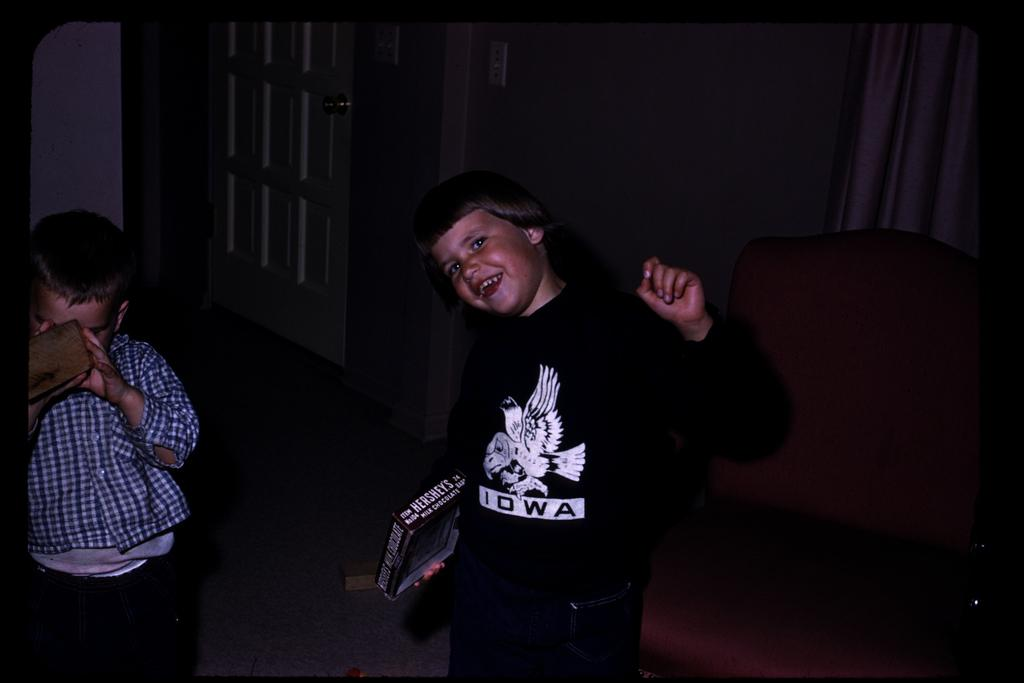How many kids are in the image? There are two kids in the center of the image. What can be seen in the background of the image? There is a door and a wall in the background of the image. Where is the chair located in the image? The chair is to the right side of the image. What type of support does the frame of the door require in the image? There is no mention of a frame or support for the door in the image; only the door itself is visible. 